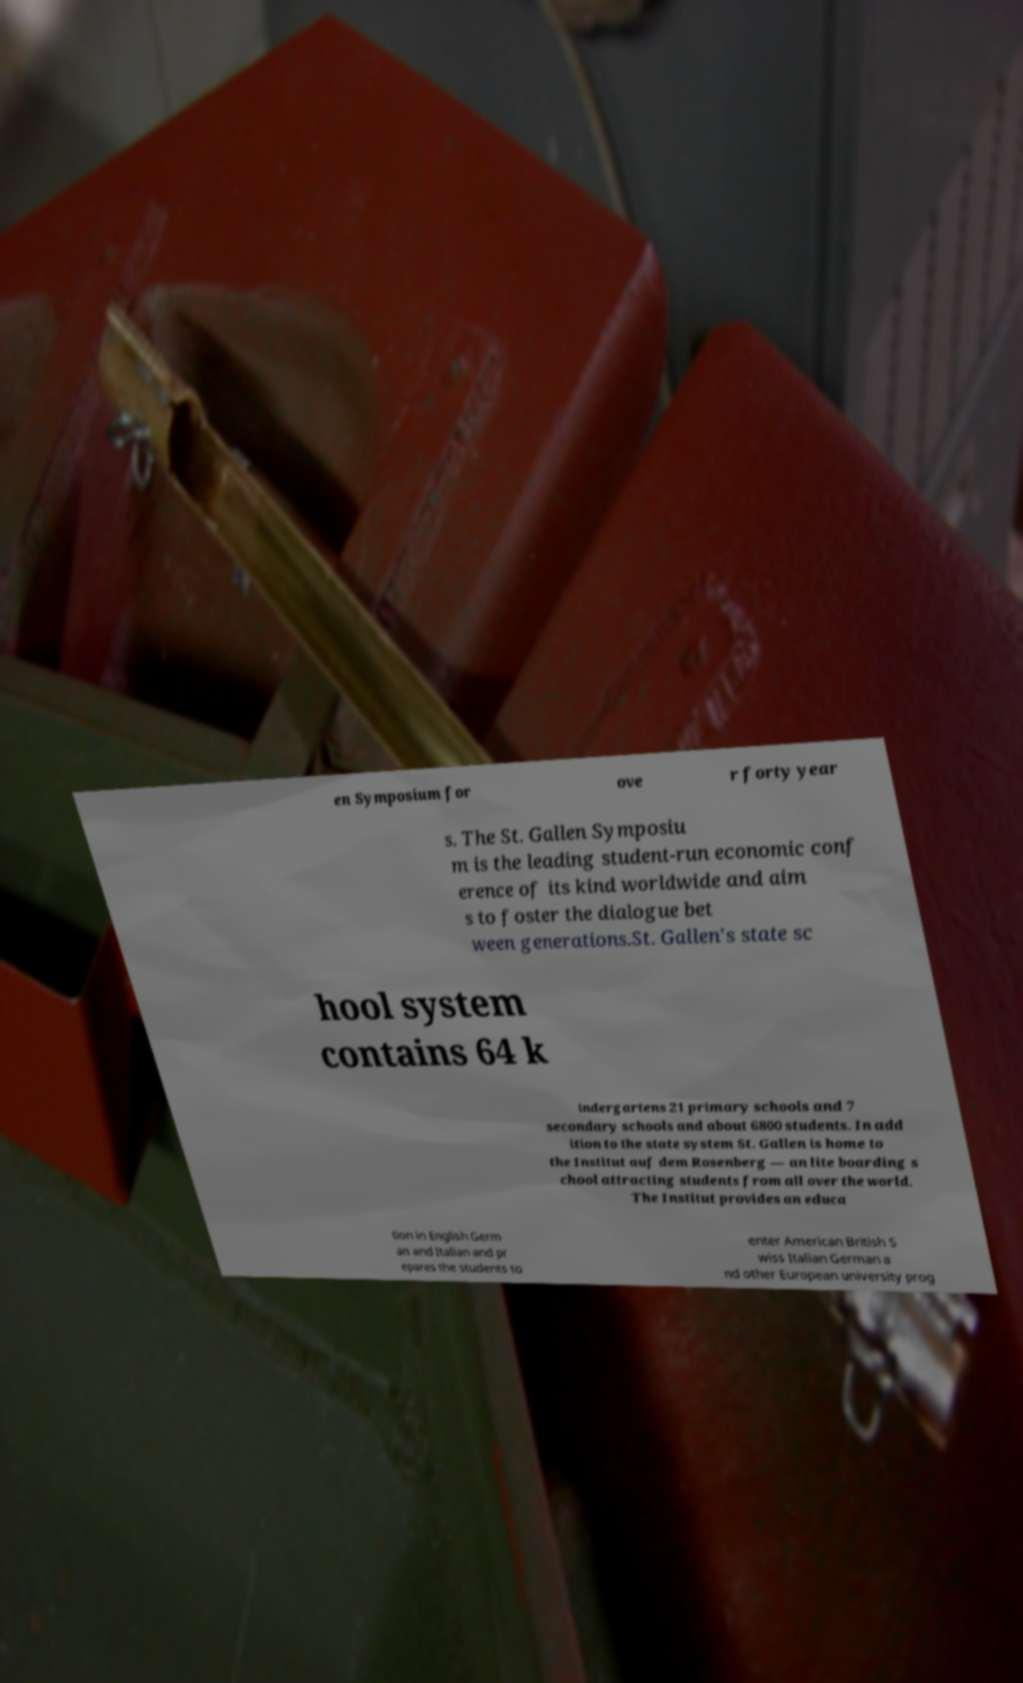Can you read and provide the text displayed in the image?This photo seems to have some interesting text. Can you extract and type it out for me? en Symposium for ove r forty year s. The St. Gallen Symposiu m is the leading student-run economic conf erence of its kind worldwide and aim s to foster the dialogue bet ween generations.St. Gallen's state sc hool system contains 64 k indergartens 21 primary schools and 7 secondary schools and about 6800 students. In add ition to the state system St. Gallen is home to the Institut auf dem Rosenberg — an lite boarding s chool attracting students from all over the world. The Institut provides an educa tion in English Germ an and Italian and pr epares the students to enter American British S wiss Italian German a nd other European university prog 